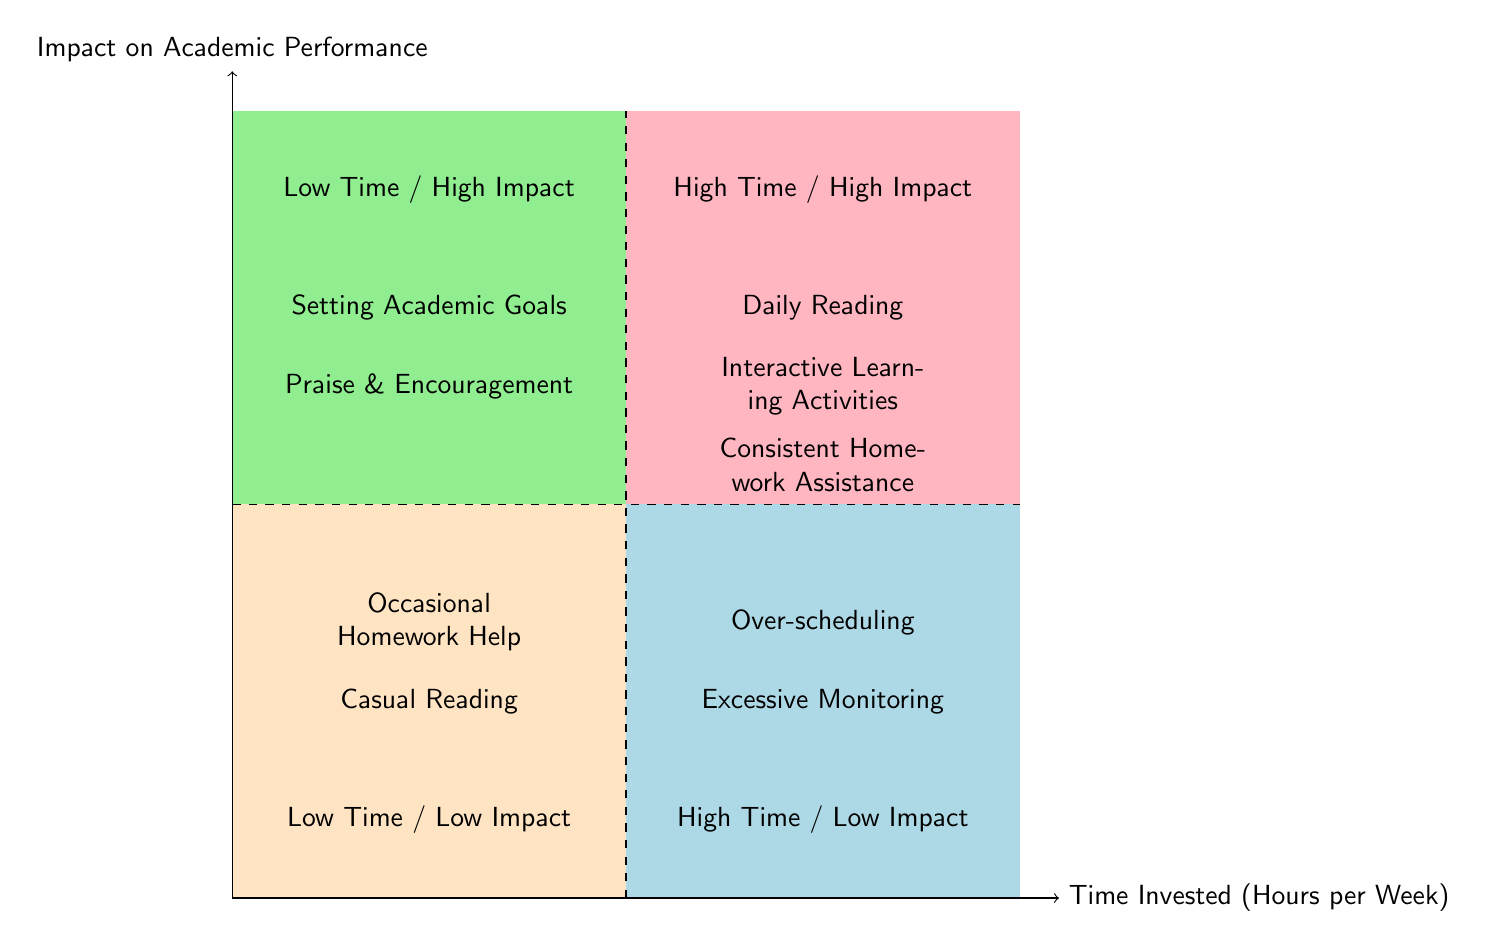What are the elements in the Low Time / Low Impact quadrant? The Low Time / Low Impact quadrant contains two elements: Occasional Homework Help and Casual Reading. By examining the elements listed individually in this specific quadrant, we can identify them clearly.
Answer: Occasional Homework Help, Casual Reading How many elements are in the High Time / High Impact quadrant? The High Time / High Impact quadrant has three elements: Daily Reading, Interactive Learning Activities, and Consistent Homework Assistance. Counting each element listed in this quadrant confirms the total.
Answer: 3 What is the main focus of the Low Time / High Impact quadrant? The Low Time / High Impact quadrant focuses on strategies that require less time investment but yield a significant positive impact on academic performance. Both elements in this quadrant emphasize goal-setting and positive reinforcement, showing their important role in education.
Answer: Setting Academic Goals, Praise & Encouragement What impact do excessive monitoring and over-scheduling have on academic performance? Both excessive monitoring and over-scheduling fall under the High Time / Low Impact quadrant, indicating that they require a lot of time but do not effectively enhance academic performance. It illustrates the nature of these activities as ultimately not productive in improving academic outcomes.
Answer: Low Impact What kind of activities are prioritized for high impact with low time investment? In the Low Time / High Impact quadrant, activities prioritized are those like Setting Academic Goals and Praise & Encouragement, which suggest that meaningful parental involvement does not always require significant time yet can foster a positive academic environment.
Answer: Setting Academic Goals, Praise & Encouragement Why might daily reading be categorized in the High Time / High Impact quadrant? Daily Reading is in the High Time / High Impact quadrant because it involves a consistent and significant time commitment of 30 minutes each day and is known to substantially influence a child's academic performance positively through improved literacy skills. This places it firmly in this quadrant as both a high-demand and efficacious activity.
Answer: High Time / High Impact What distinguishes the relationship between time invested and academic impact in this diagram? The diagram distinctly categorizes activities based on their time investment on the horizontal axis and their academic impact on the vertical axis. This visual structure allows for a comparative understanding of how varying time commitments correlate to different effects on children's academic performance.
Answer: Different correlation Which quadrant contains activities that provide a significant impact with minimal time investment? The Low Time / High Impact quadrant includes activities that provide significant academic benefits while demanding only a small amount of time, demonstrating effective strategies for parents who may have limited hours to spare for academic involvement.
Answer: Low Time / High Impact 